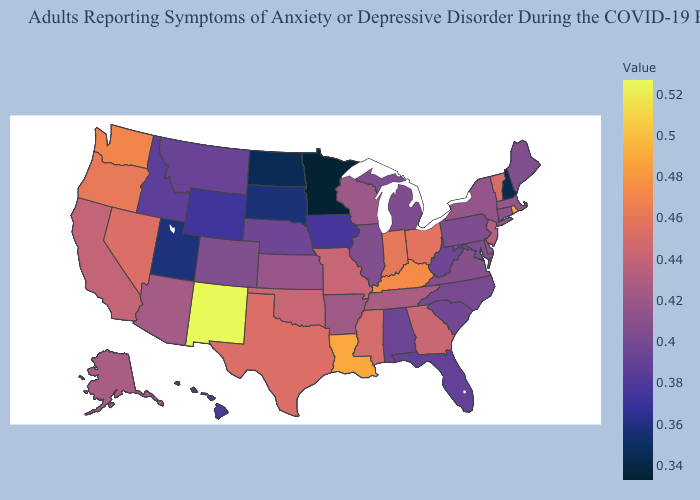Which states have the lowest value in the USA?
Short answer required. Minnesota. Which states have the lowest value in the USA?
Write a very short answer. Minnesota. Among the states that border Louisiana , which have the highest value?
Be succinct. Texas. Does Delaware have a lower value than Oklahoma?
Be succinct. Yes. 